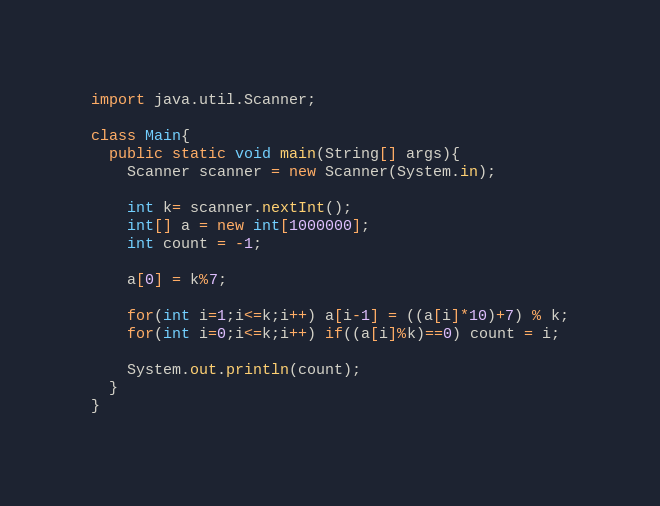Convert code to text. <code><loc_0><loc_0><loc_500><loc_500><_Java_>import java.util.Scanner;

class Main{
  public static void main(String[] args){
  	Scanner scanner = new Scanner(System.in);

	int k= scanner.nextInt();
    int[] a = new int[1000000];
    int count = -1;
    
    a[0] = k%7;
    
    for(int i=1;i<=k;i++) a[i-1] = ((a[i]*10)+7) % k;
    for(int i=0;i<=k;i++) if((a[i]%k)==0) count = i;
    
    System.out.println(count);
  }
}</code> 